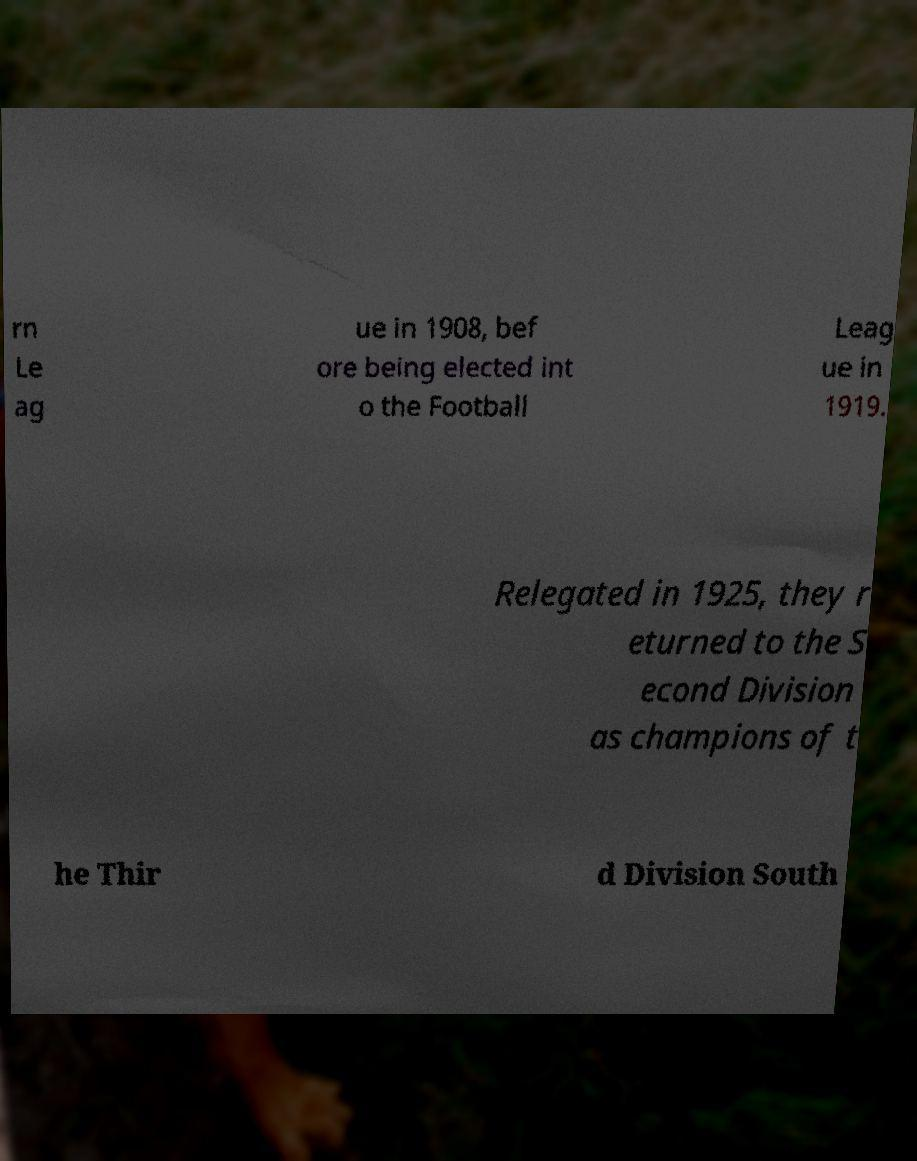Can you read and provide the text displayed in the image?This photo seems to have some interesting text. Can you extract and type it out for me? rn Le ag ue in 1908, bef ore being elected int o the Football Leag ue in 1919. Relegated in 1925, they r eturned to the S econd Division as champions of t he Thir d Division South 